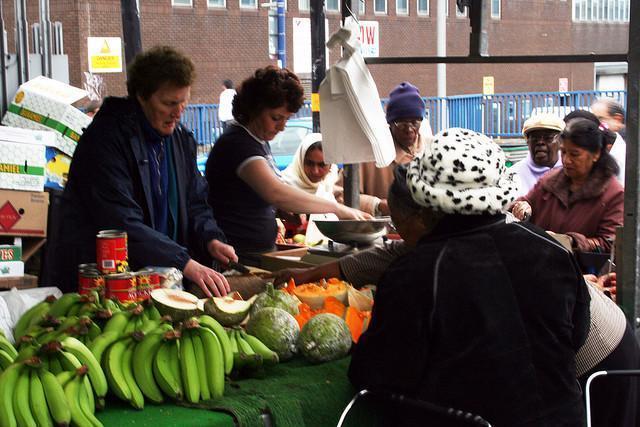How many bananas are there?
Give a very brief answer. 3. How many people are there?
Give a very brief answer. 7. 